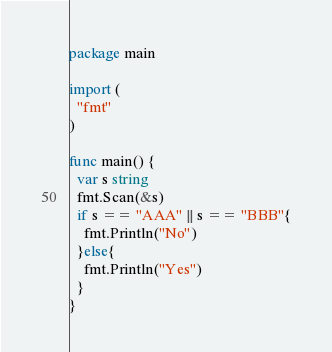<code> <loc_0><loc_0><loc_500><loc_500><_Go_>package main

import (
  "fmt"
)

func main() {
  var s string
  fmt.Scan(&s)
  if s == "AAA" || s == "BBB"{
    fmt.Println("No")
  }else{
    fmt.Println("Yes")
  }
}</code> 